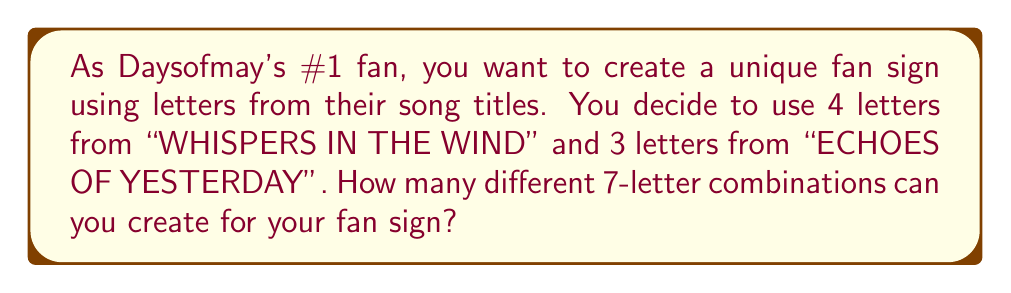Can you answer this question? Let's approach this step-by-step:

1) First, we need to count the number of letters in each song title:
   "WHISPERS IN THE WIND" has 18 unique letters (W, H, I, S, P, E, R, N, T, D)
   "ECHOES OF YESTERDAY" has 11 unique letters (E, C, H, O, S, F, Y, T, R, D, A)

2) We need to choose 4 letters from the first title and 3 from the second. This is a combination problem.

3) For the first selection (4 letters from 18):
   We use the combination formula: $${18 \choose 4} = \frac{18!}{4!(18-4)!} = \frac{18!}{4!14!} = 3060$$

4) For the second selection (3 letters from 11):
   $${11 \choose 3} = \frac{11!}{3!(11-3)!} = \frac{11!}{3!8!} = 165$$

5) By the multiplication principle, the total number of ways to select the letters is:
   $$3060 \times 165 = 504,900$$

6) However, this only gives us the number of ways to select the letters. We also need to consider the number of ways to arrange these 7 letters.

7) The number of permutations of 7 letters is:
   $$7! = 7 \times 6 \times 5 \times 4 \times 3 \times 2 \times 1 = 5040$$

8) Therefore, the total number of unique fan sign combinations is:
   $$504,900 \times 5040 = 2,544,696,000$$
Answer: $$2,544,696,000$$ unique fan sign combinations 